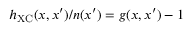<formula> <loc_0><loc_0><loc_500><loc_500>h _ { X C } ( x , x ^ { \prime } ) / n ( x ^ { \prime } ) = g ( x , x ^ { \prime } ) - 1</formula> 